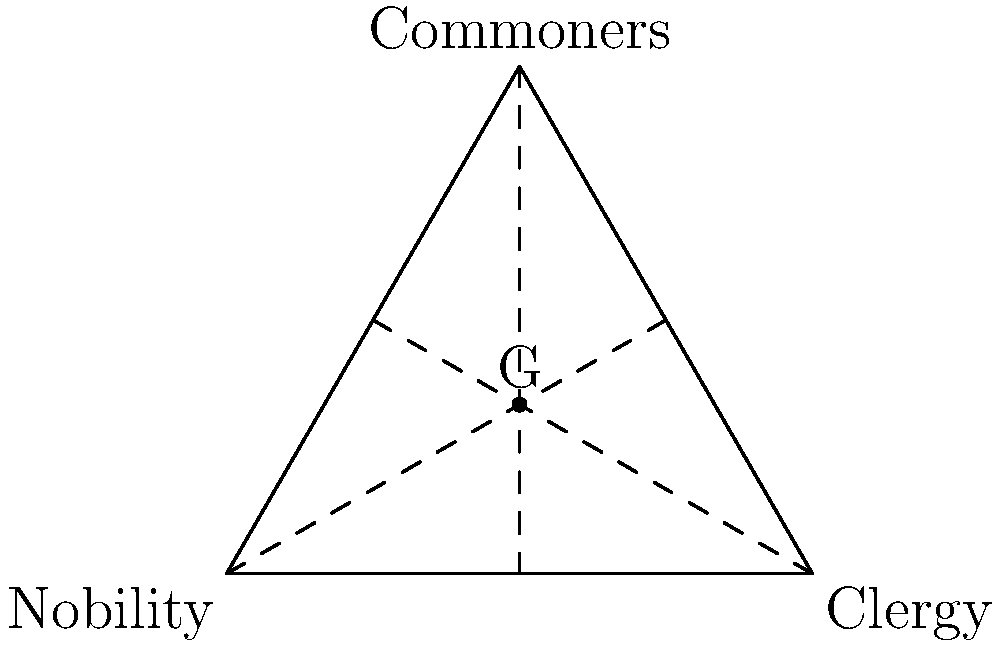In the context of a medieval European society, the diagram represents the three main social classes: Nobility, Clergy, and Commoners. If we consider these classes as subgroups of the entire society (group G), which of the following statements about the order of subgroups is most likely to be true for this historical social structure?

a) $|Nobility| > |Clergy| > |Commoners|$
b) $|Commoners| > |Nobility| > |Clergy|$
c) $|Clergy| > |Nobility| > |Commoners|$
d) $|Commoners| > |Clergy| > |Nobility|$

Where $|X|$ denotes the order (number of elements) of subgroup X. To answer this question, we need to consider the historical context of medieval European society and apply basic principles of group theory:

1. In group theory, the order of a subgroup refers to the number of elements in that subgroup.

2. In medieval European society, the social hierarchy was typically represented as a pyramid with a broad base and a narrow top.

3. Let's analyze each social class:
   - Commoners: This group included peasants, serfs, craftsmen, and merchants. It formed the largest portion of the population.
   - Nobility: This group included royalty, lords, and knights. It was much smaller than the commoner class but generally larger than the clergy.
   - Clergy: This group included religious figures from priests to bishops. It was typically the smallest of the three main classes.

4. Considering the relative sizes of these groups, we can establish that:
   $|Commoners| > |Nobility| > |Clergy|$

5. This order reflects the typical distribution of population in medieval European societies, where the vast majority were commoners, a small percentage were nobility, and an even smaller percentage were clergy.

6. In the context of group theory, if we consider the entire society as group G, these social classes would be subgroups of G, and their orders would follow the same relationship.

Therefore, the most historically accurate statement about the order of subgroups in this social structure is option b: $|Commoners| > |Nobility| > |Clergy|$.
Answer: b) $|Commoners| > |Nobility| > |Clergy|$ 